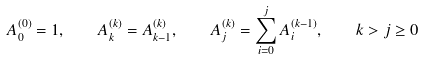Convert formula to latex. <formula><loc_0><loc_0><loc_500><loc_500>A _ { 0 } ^ { ( 0 ) } = 1 , \quad A _ { k } ^ { ( k ) } = A _ { k - 1 } ^ { ( k ) } , \quad A _ { j } ^ { ( k ) } = \sum _ { i = 0 } ^ { j } A _ { i } ^ { ( k - 1 ) } , \quad k > j \geq 0</formula> 